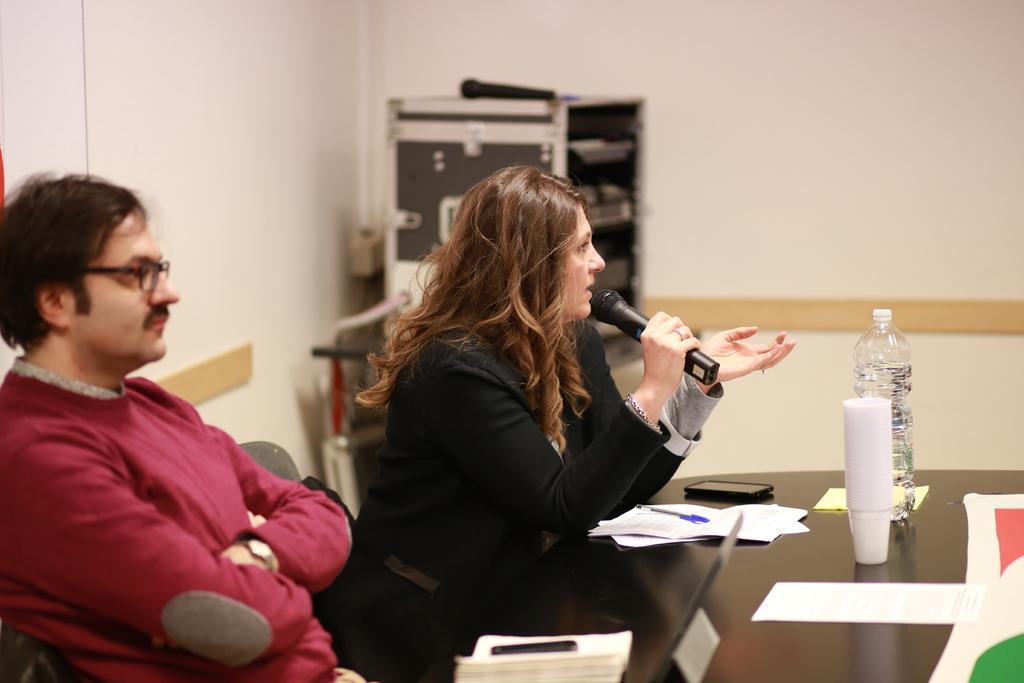Can you describe this image briefly? In the image there are two people sitting in front of a table and the woman is speaking something, on the table there are papers, a mobile, glasses, a water bottle and other things. In the background there are some gadgets and behind that there is a wall. 